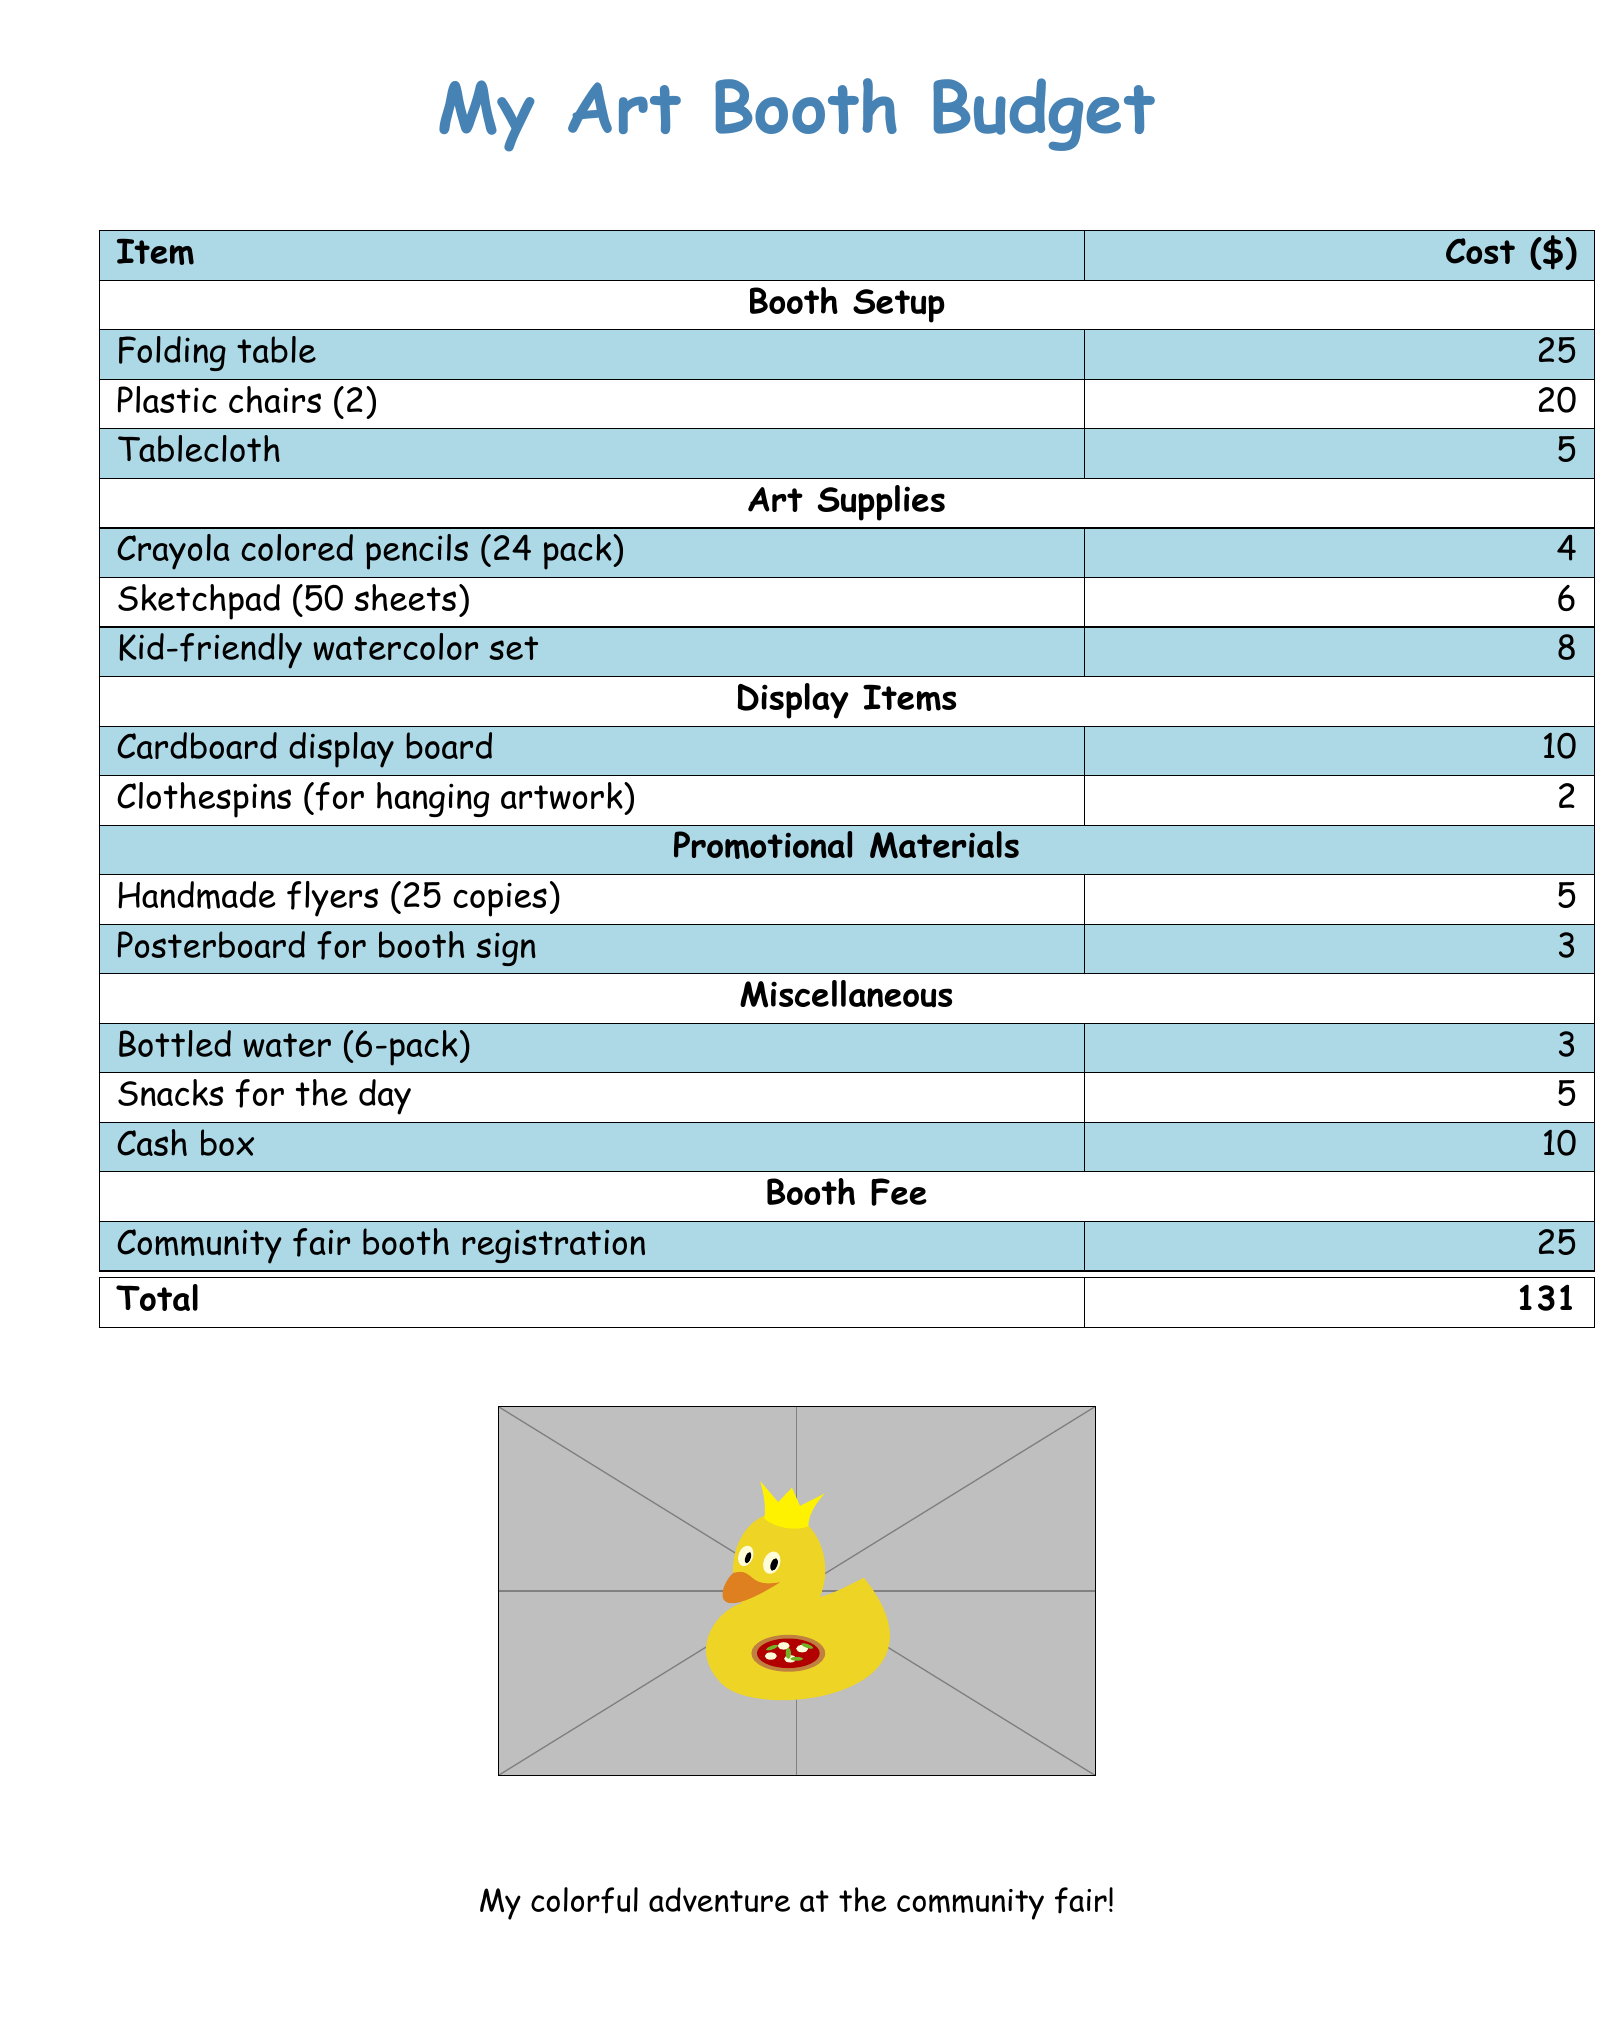What is the total cost of setting up the booth? The total cost is calculated by summing all the individual costs listed in the document.
Answer: 131 How much does a folding table cost? The document lists the specific cost of a folding table under booth setup.
Answer: 25 What is the cost of a kid-friendly watercolor set? This cost is found under the art supplies section.
Answer: 8 How many plastic chairs are included in the budget? The document specifies the number of plastic chairs purchased.
Answer: 2 What is the cost of bottled water? The price for bottled water is listed under miscellaneous items.
Answer: 3 What item costs the least? The document indicates various costs for all items, and the least expensive is the clothespins.
Answer: 2 How much is allocated for promotional materials? The total cost for promotional materials can be calculated by adding the individual costs listed in that section.
Answer: 8 What is the total cost of art supplies? The total cost of art supplies is the sum of the individual prices found in that section.
Answer: 18 How much do the snacks cost? The cost for snacks is explicitly stated in the miscellaneous section.
Answer: 5 